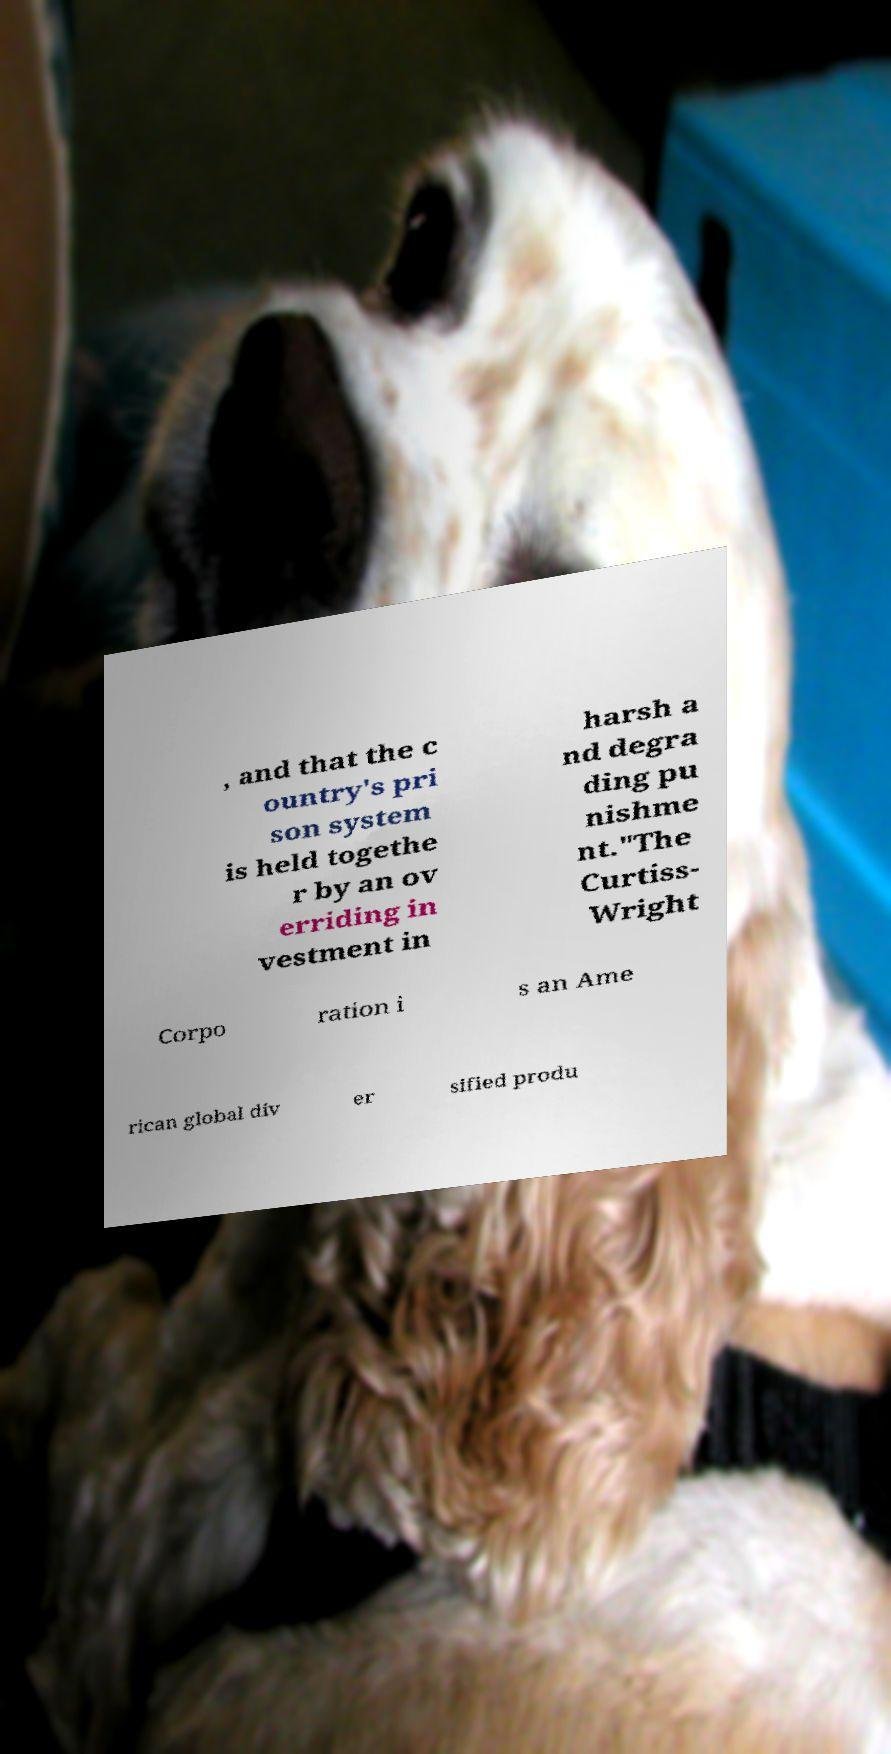Can you accurately transcribe the text from the provided image for me? , and that the c ountry's pri son system is held togethe r by an ov erriding in vestment in harsh a nd degra ding pu nishme nt."The Curtiss- Wright Corpo ration i s an Ame rican global div er sified produ 